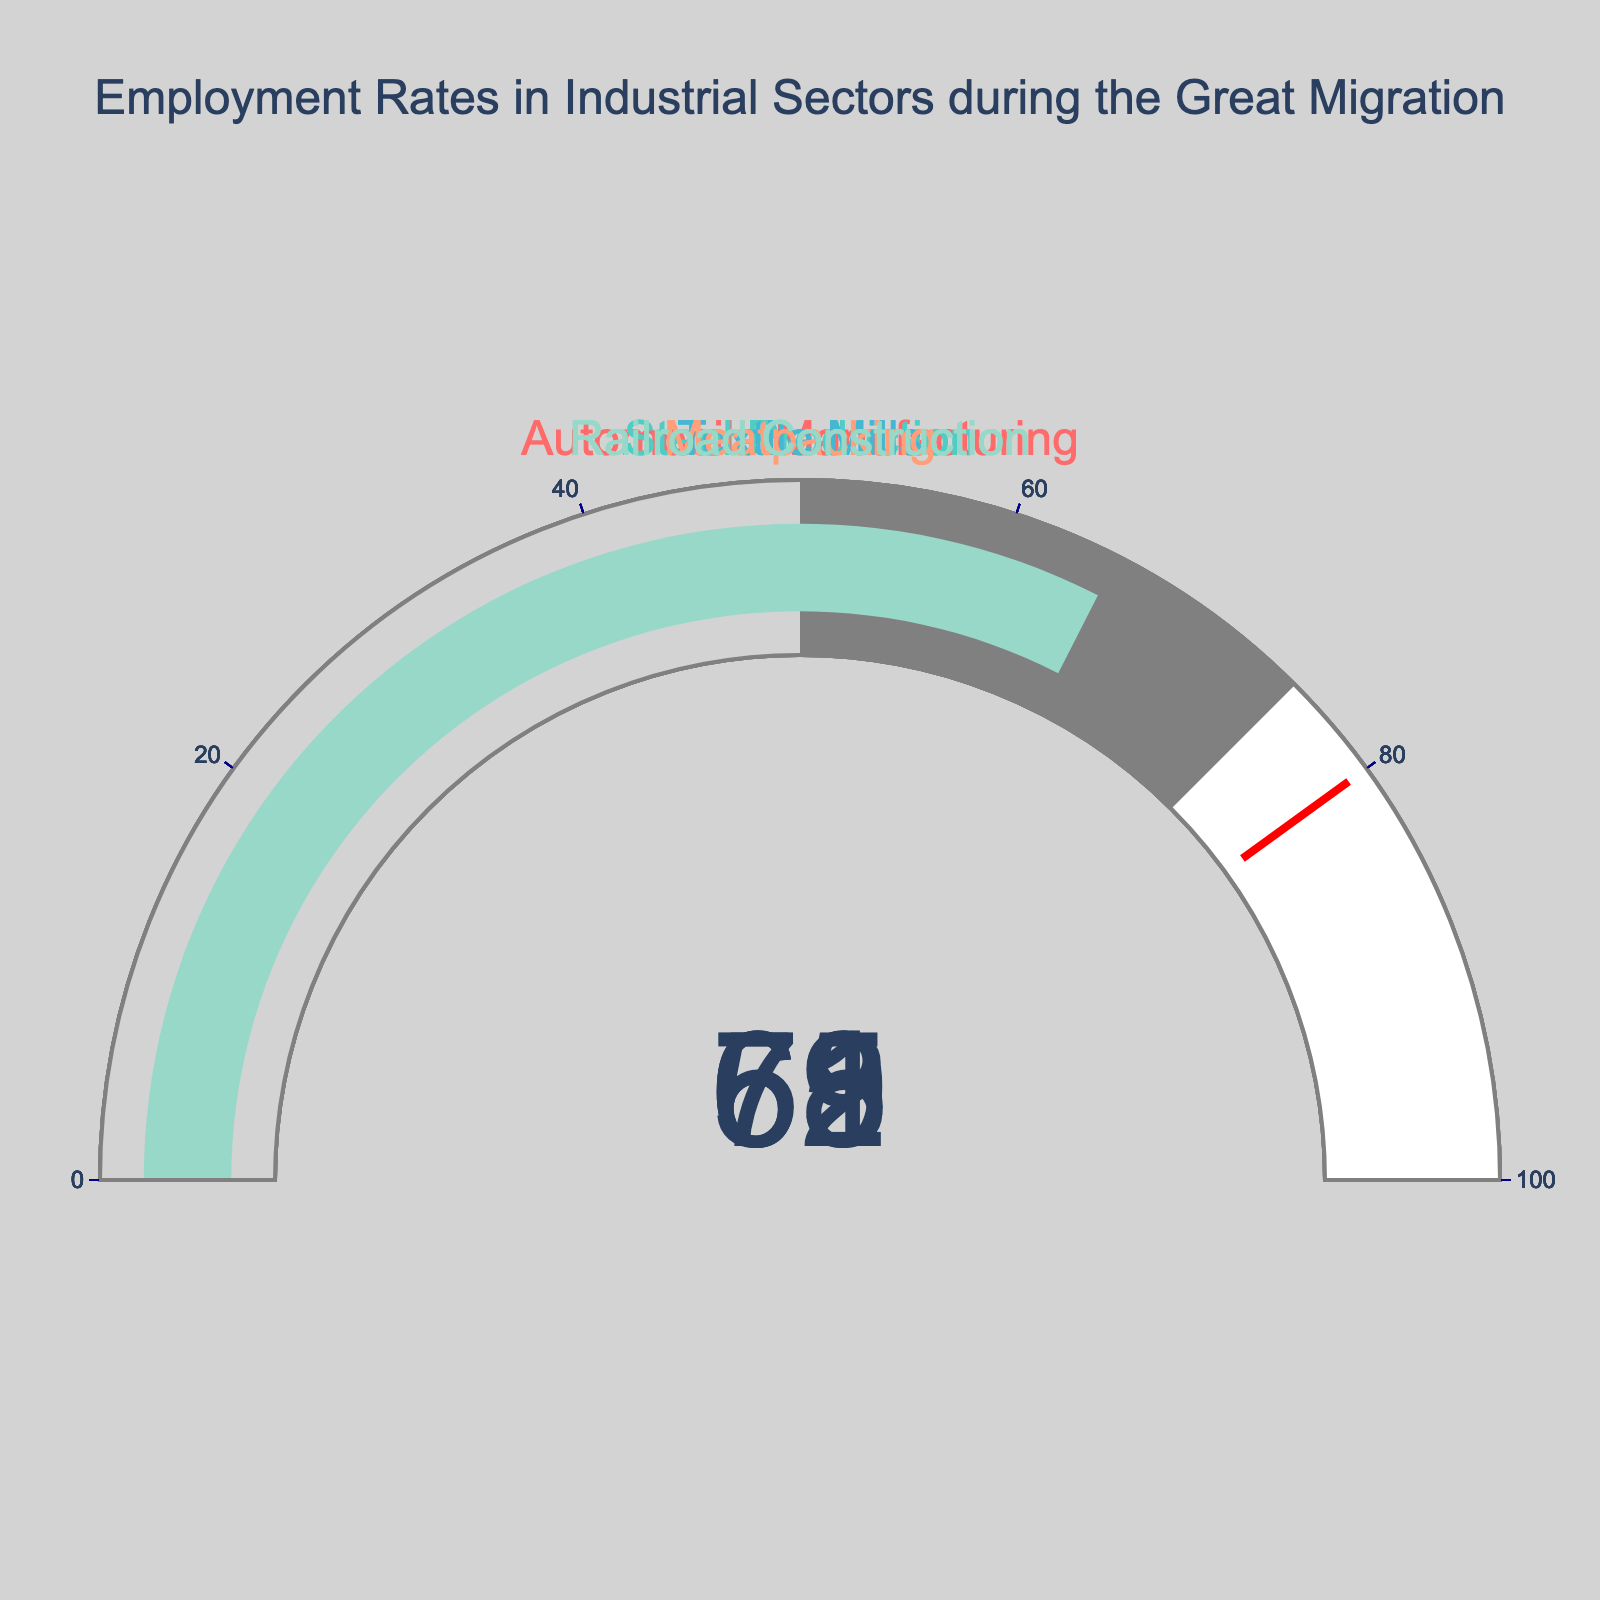How many industrial sectors are represented in the gauge chart? The gauge chart displays gauges for each industrial sector depicted. There are five distinct gauges shown, indicating five different sectors.
Answer: Five Which sector has the highest employment rate? By observing the values displayed by the gauges, the sector with the highest employment rate is the one with the highest value, which is 72. This corresponds to Steel Production.
Answer: Steel Production What is the difference in employment rates between the Automobile Manufacturing and Textile Mills sectors? The employment rates for Automobile Manufacturing and Textile Mills are 68 and 61, respectively. The difference is calculated as 68 - 61 = 7.
Answer: 7 What is the average employment rate across all five sectors? To calculate the average employment rate, sum the employment rates of all sectors and divide by the number of sectors. The total is 68 + 72 + 61 + 59 + 65 = 325, and the average is 325 / 5 = 65.
Answer: 65 Which sector has the lowest employment rate? The sector with the lowest employment rate is the one with the smallest value on the gauge chart, which is 59. This corresponds to Meatpacking.
Answer: Meatpacking Is the employment rate for Railroad Construction greater than the average employment rate across all sectors? The employment rate for Railroad Construction is 65, and the average employment rate across all sectors is also 65. Therefore, the employment rate for Railroad Construction is equal to the average.
Answer: No How many sectors have an employment rate above 60? By examining each gauge, the sectors with employment rates above 60 are Automobile Manufacturing (68), Steel Production (72), and Textile Mills (61). Therefore, three sectors have rates above 60.
Answer: Three What is the combined employment rate for the Textile Mills and Meatpacking sectors? The employment rates for Textile Mills and Meatpacking are 61 and 59, respectively. Their combined employment rate is 61 + 59 = 120.
Answer: 120 By how much does Steel Production's employment rate exceed Meatpacking's employment rate? The employment rate for Steel Production is 72, and for Meatpacking it is 59. The difference is 72 - 59 = 13.
Answer: 13 Which two sectors have employment rates closest in value? The closest employment rates are for Railroad Construction (65) and Automobile Manufacturing (68) with a difference of 68 - 65 = 3. This is the smallest difference among all comparison combinations.
Answer: Railroad Construction and Automobile Manufacturing 